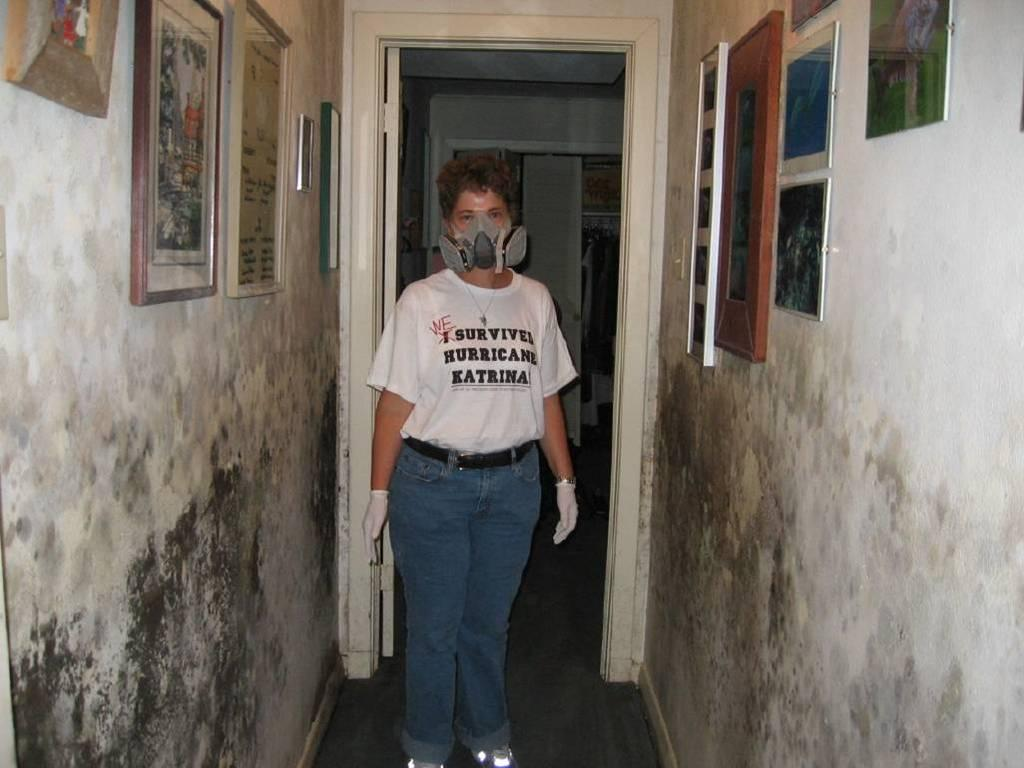What is the person in the image doing? The person is standing in the image. What is the person wearing on their face? The person is wearing a mask. What can be seen on the wall in the image? There are photo frames on the wall. What architectural feature is present in the image? There is a door in the image. What type of wire is being used to hold the person up in the image? There is no wire present in the image, and the person is standing on their own. In which direction is the person facing in the image? The image does not provide enough information to determine the direction the person is facing. 